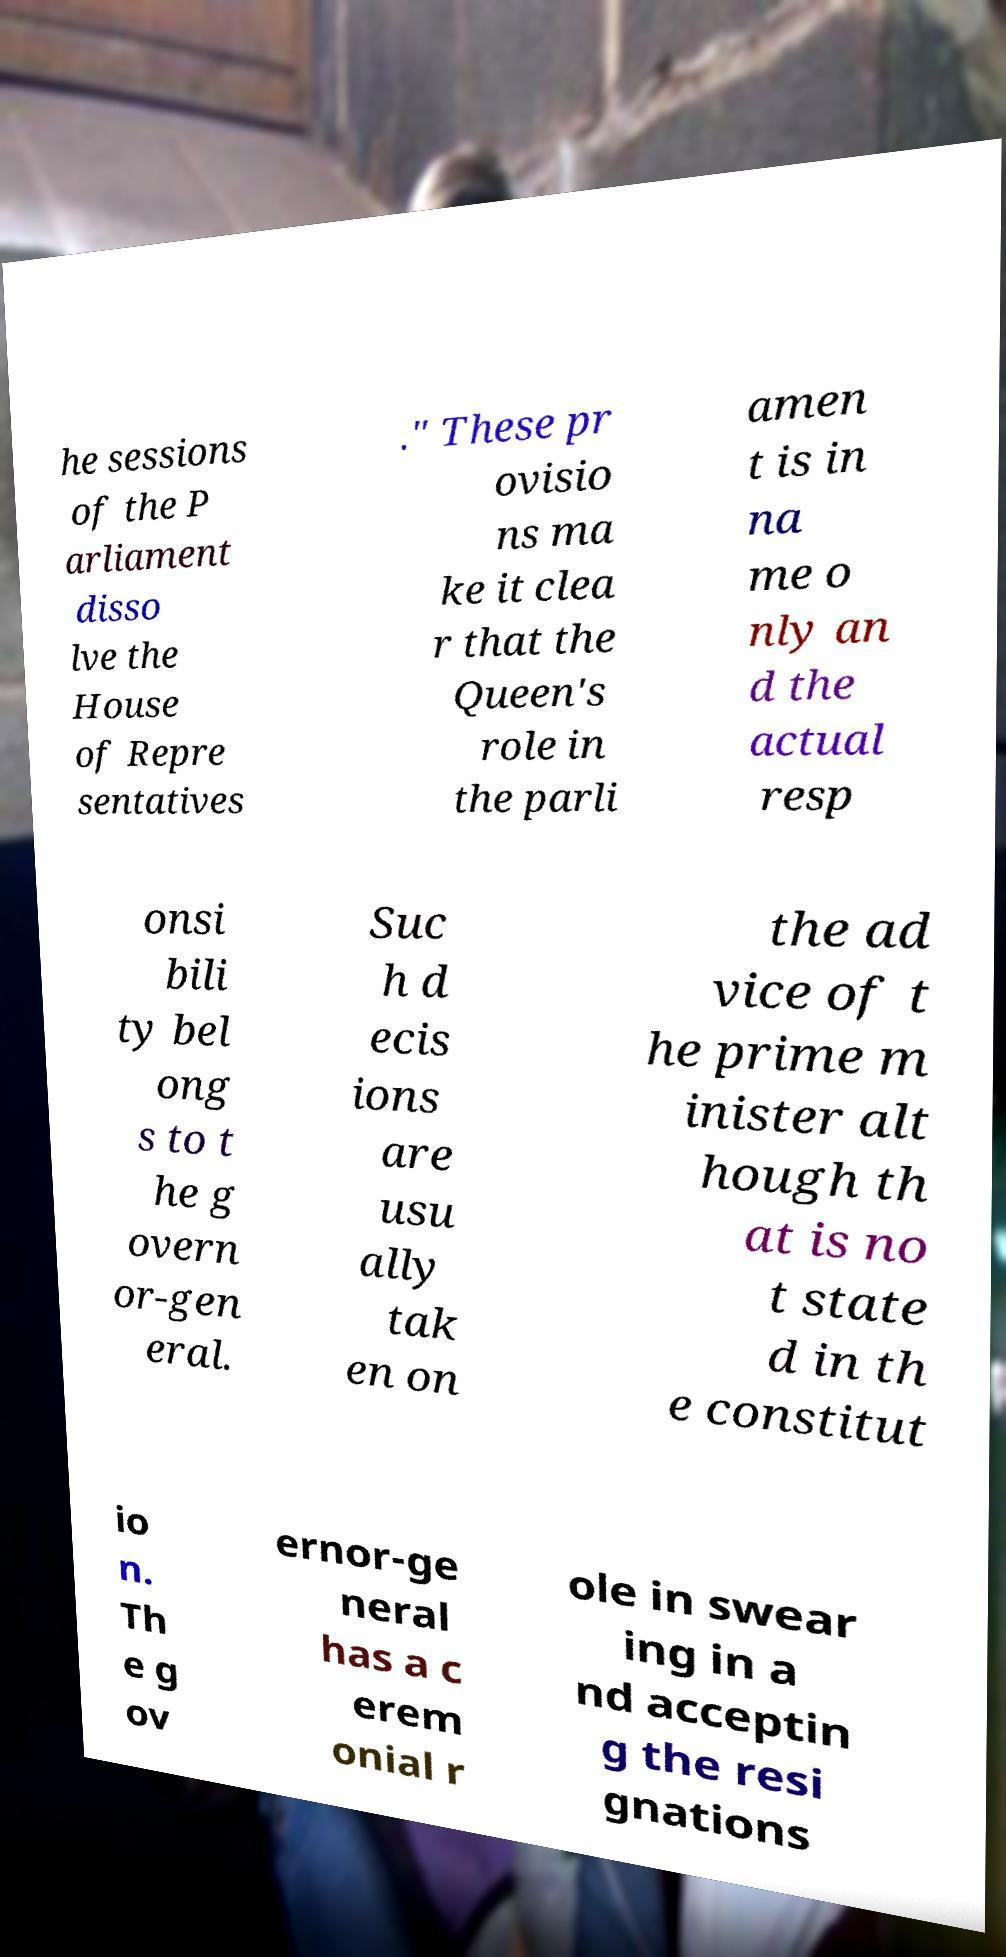Could you extract and type out the text from this image? he sessions of the P arliament disso lve the House of Repre sentatives ." These pr ovisio ns ma ke it clea r that the Queen's role in the parli amen t is in na me o nly an d the actual resp onsi bili ty bel ong s to t he g overn or-gen eral. Suc h d ecis ions are usu ally tak en on the ad vice of t he prime m inister alt hough th at is no t state d in th e constitut io n. Th e g ov ernor-ge neral has a c erem onial r ole in swear ing in a nd acceptin g the resi gnations 